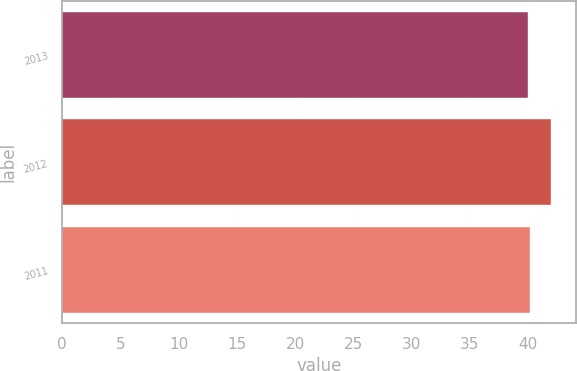Convert chart. <chart><loc_0><loc_0><loc_500><loc_500><bar_chart><fcel>2013<fcel>2012<fcel>2011<nl><fcel>40<fcel>42<fcel>40.2<nl></chart> 